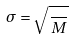<formula> <loc_0><loc_0><loc_500><loc_500>\sigma = \sqrt { \frac { } { M } }</formula> 